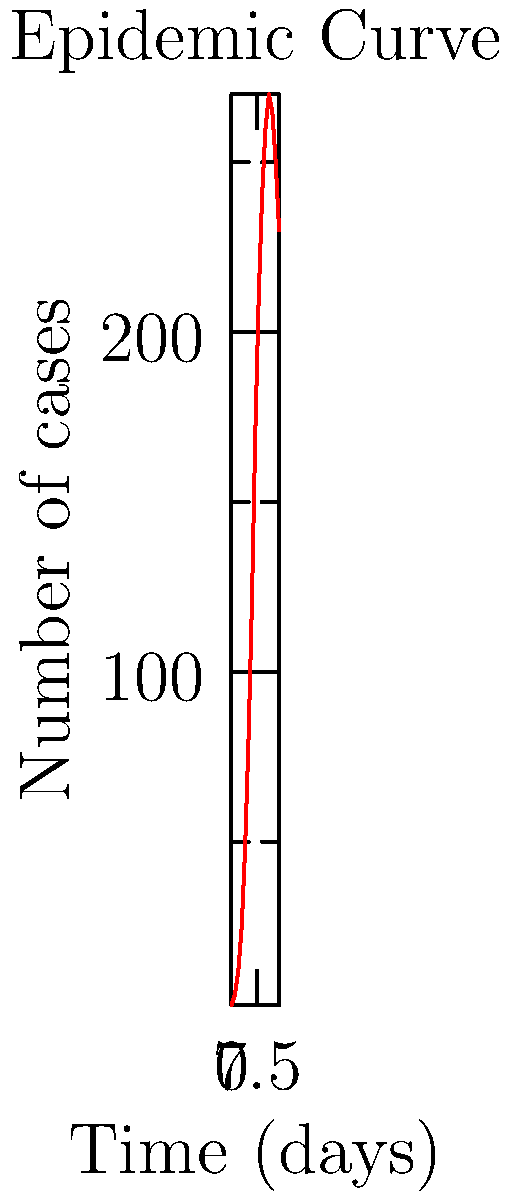Based on the epidemic curve shown, at approximately which day does the outbreak reach its peak, and what does this suggest about the progression of the outbreak? To answer this question, we need to analyze the epidemic curve:

1. Observe the trend: The curve shows an initial increase, reaches a maximum, and then starts to decrease.

2. Identify the peak: The highest point on the curve represents the peak of the outbreak.

3. Determine the day of the peak: The curve reaches its highest point at around day 11-12.

4. Interpret the peak: 
   - Before the peak: The number of new cases is increasing daily.
   - At the peak: The outbreak is at its most intense, with the highest number of new cases.
   - After the peak: The number of new cases starts to decrease.

5. Outbreak progression:
   - The curve's shape (rapid increase, peak, gradual decrease) is typical of an acute outbreak.
   - The peak at day 11-12 suggests that control measures or natural factors are starting to slow the spread of the disease.
   - The gradual decline after the peak indicates that the outbreak is being controlled, but new cases are still occurring.

6. Public health implications:
   - Resources may need to be maintained or even increased shortly after the peak to manage existing cases.
   - Control measures should be continued to ensure the decline continues.
Answer: Day 11-12; indicates transition from increasing to decreasing new cases, suggesting control measures are becoming effective. 